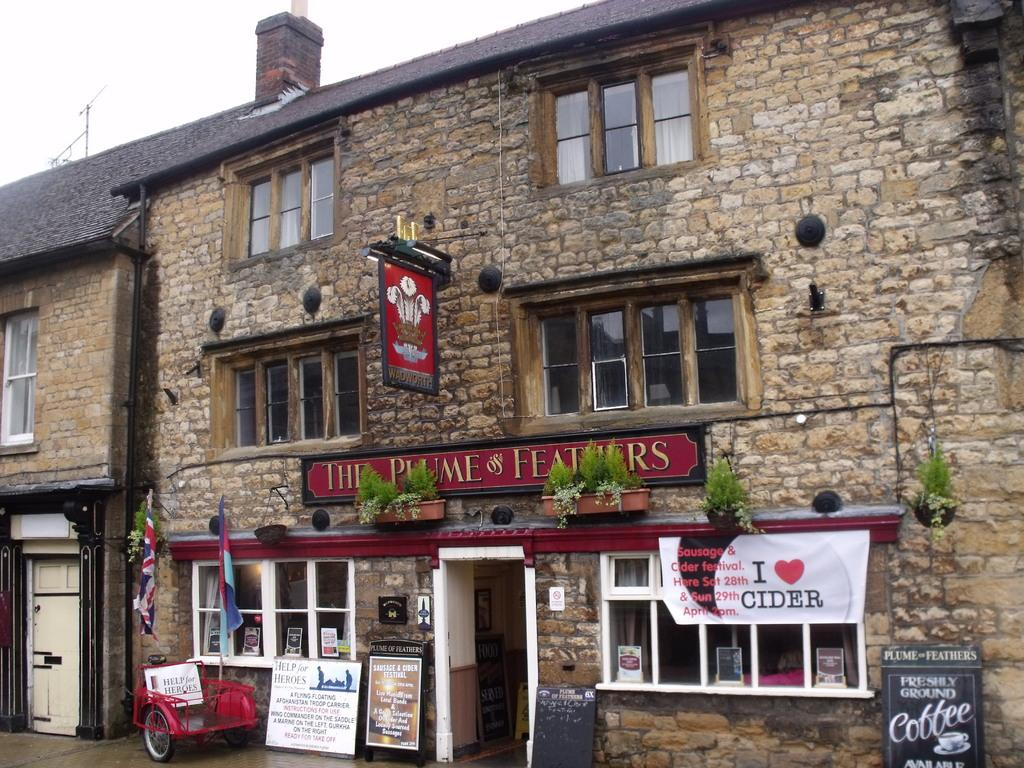What type of structure is visible in the image? There is a building with windows in the image. What other objects can be found inside the building? There are houseplants visible in the image. What decorative elements are present in the image? There are banners and flags in the image. What is visible in the background of the image? The sky with clouds is visible in the background of the image. Can you tell me how many kittens are playing near the door in the image? There is no door or kittens present in the image. 